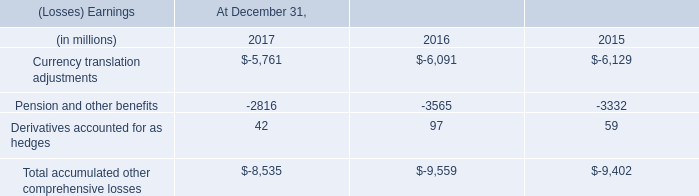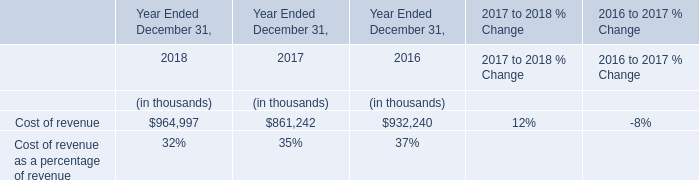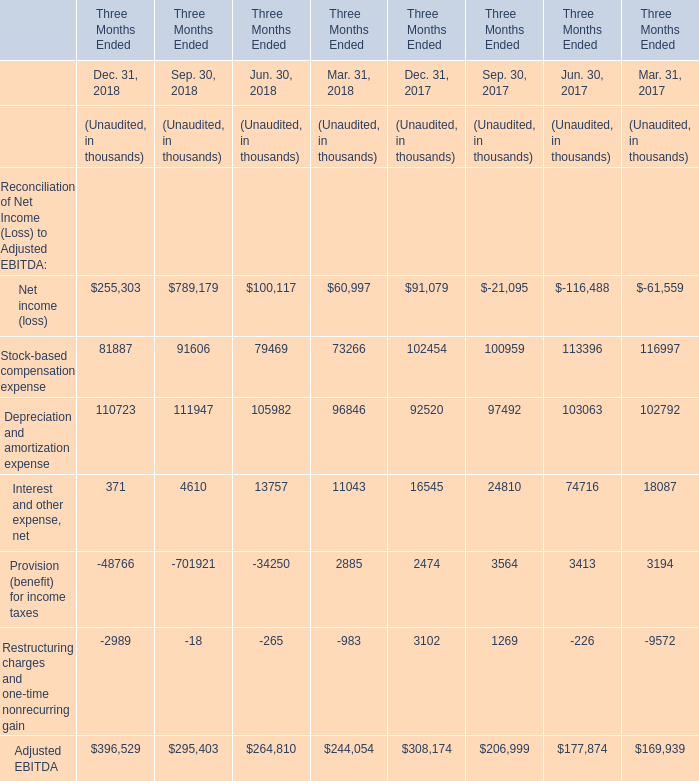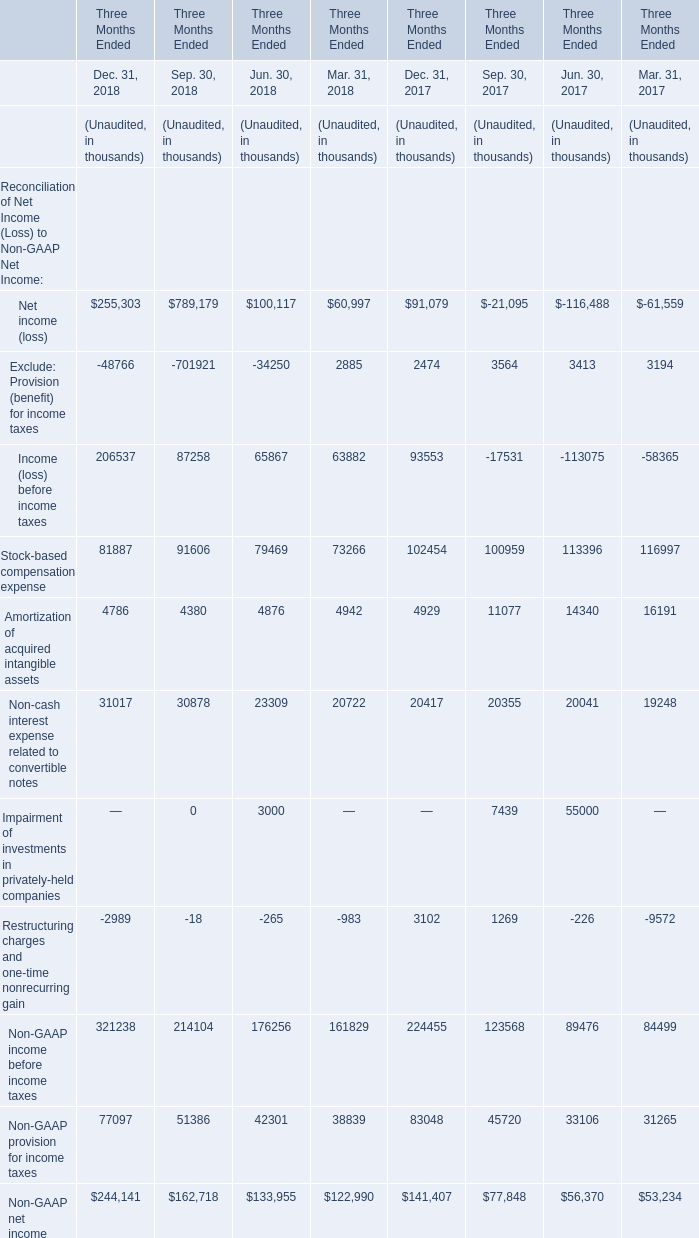What is the difference between the greatest Reconciliation of Net Income (Loss) to Non-GAAP Net Income in Dec. 31, 2018 and Dec. 31, 2017 (in thousand) 
Computations: (321238 - 224455)
Answer: 96783.0. 